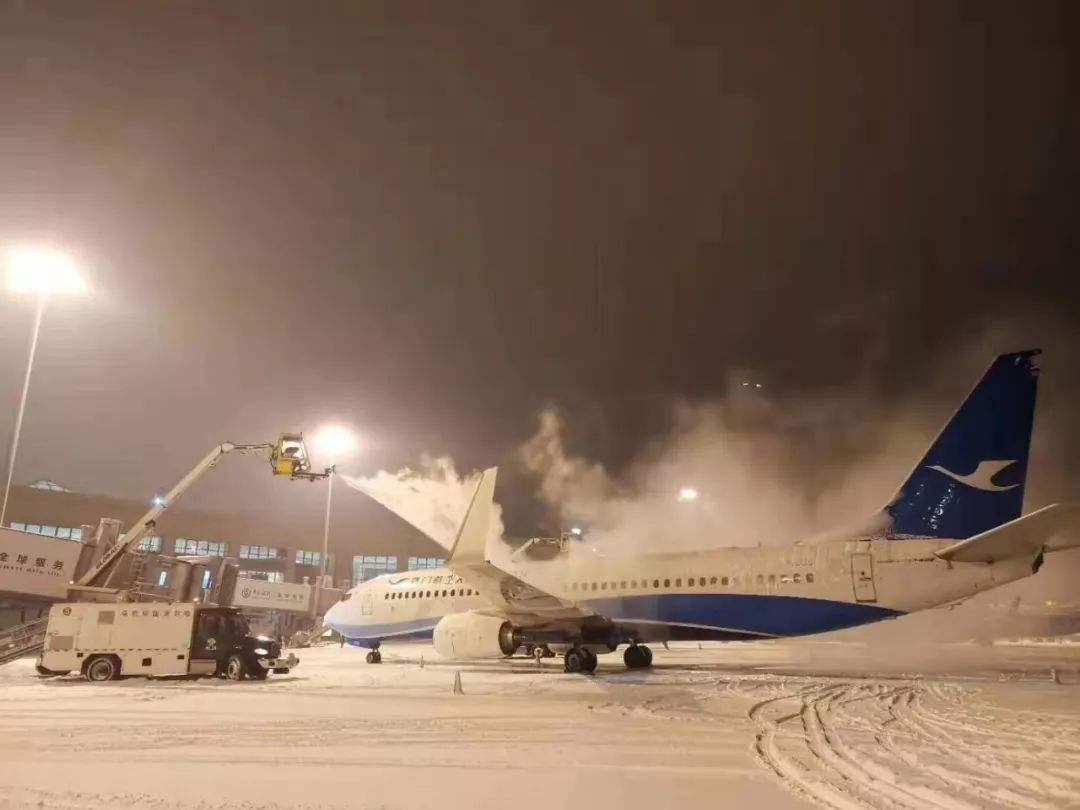How many aeroplanes are there in the image? 1 